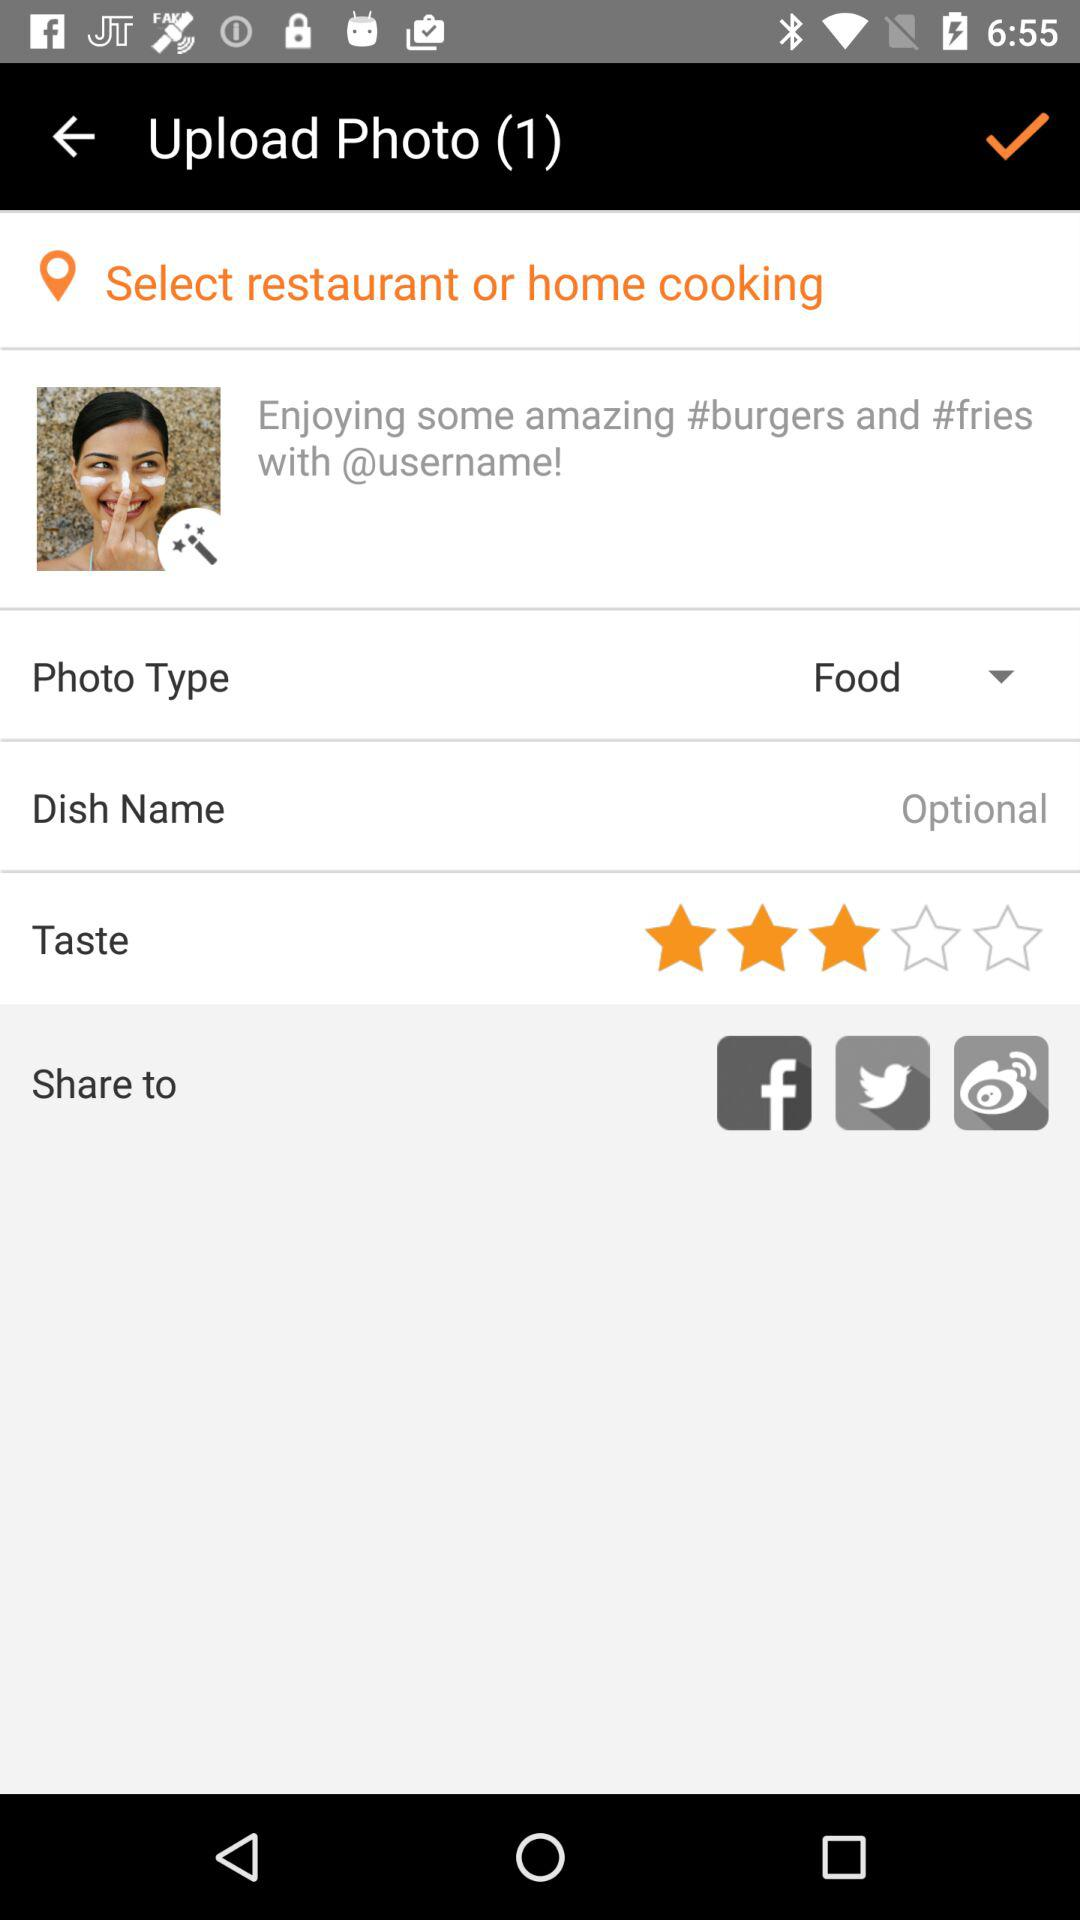What is the selected photo type? The selected photo type is food. 